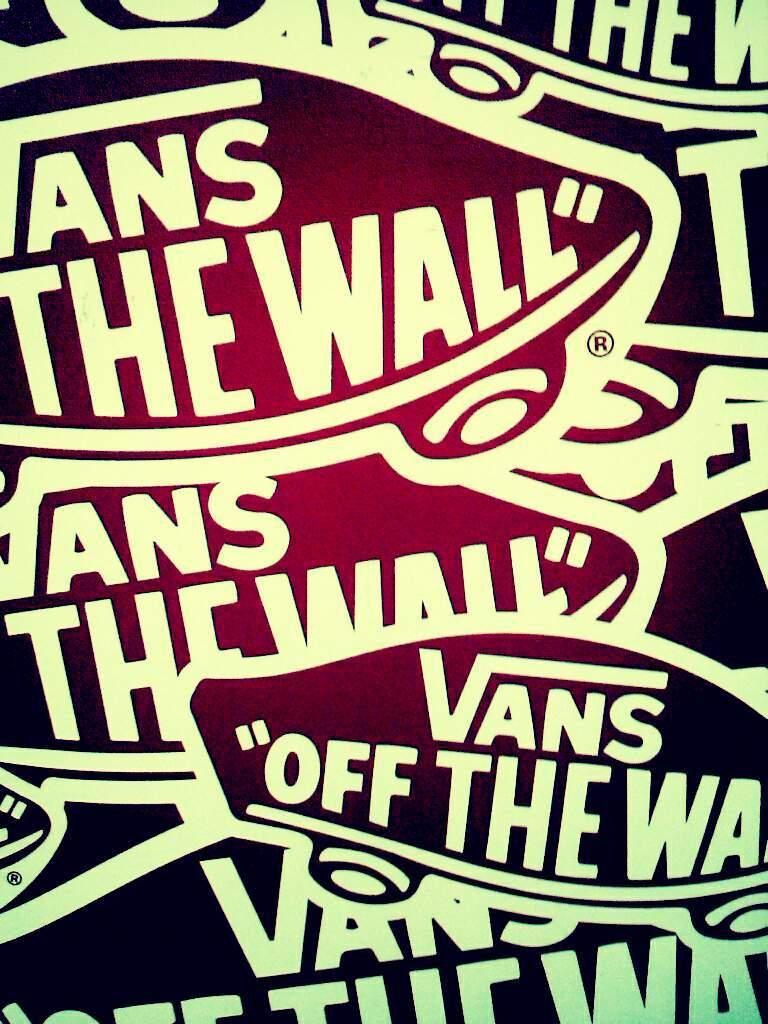What shoe company is this?
Provide a succinct answer. Vans. What is the motto of the company?
Provide a short and direct response. Off the wall. 